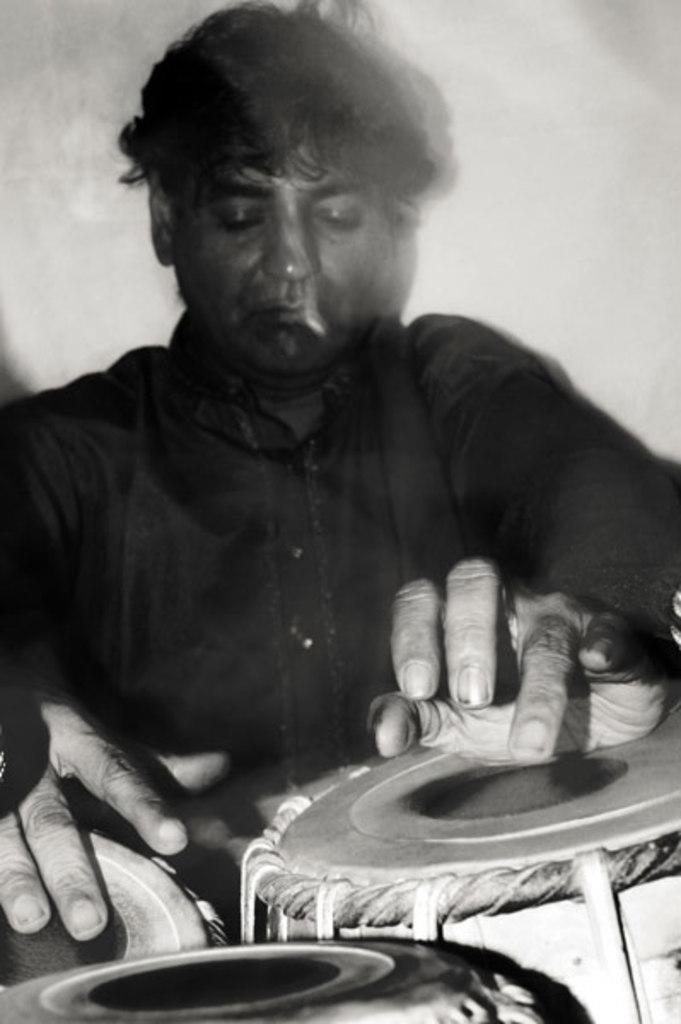Could you give a brief overview of what you see in this image? There is a man sitting and playing drums 